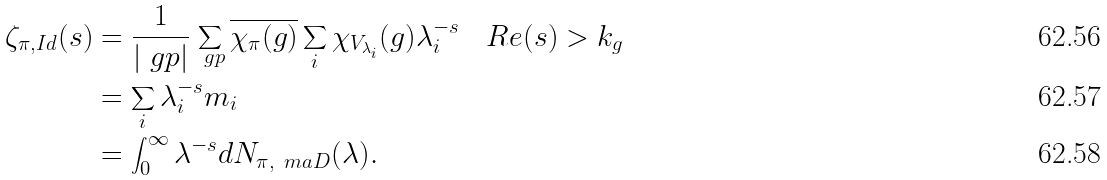Convert formula to latex. <formula><loc_0><loc_0><loc_500><loc_500>\zeta _ { \pi , I d } ( s ) & = \frac { 1 } { | \ g p | } \sum _ { \ g p } \overline { \chi _ { \pi } ( g ) } \sum _ { i } \chi _ { V _ { \lambda _ { i } } } ( g ) \lambda _ { i } ^ { - s } \quad R e ( s ) > k _ { g } \\ & = \sum _ { i } \lambda ^ { - s } _ { i } m _ { i } \\ & = \int _ { 0 } ^ { \infty } \lambda ^ { - s } d N _ { \pi , \ m a D } ( \lambda ) .</formula> 